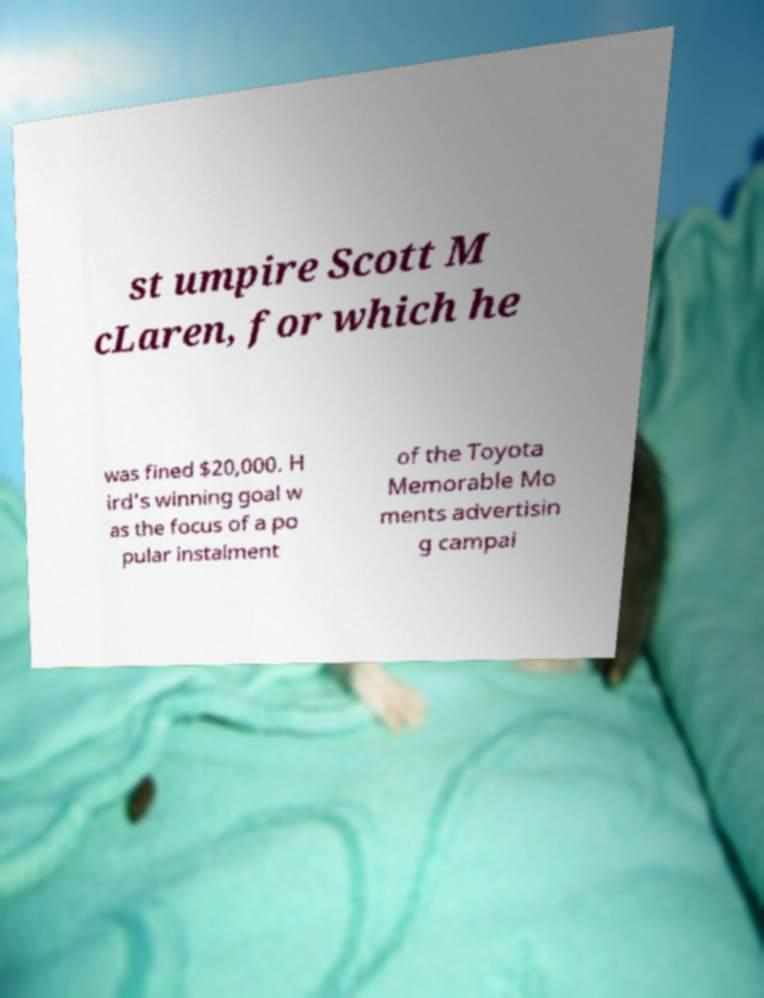I need the written content from this picture converted into text. Can you do that? st umpire Scott M cLaren, for which he was fined $20,000. H ird's winning goal w as the focus of a po pular instalment of the Toyota Memorable Mo ments advertisin g campai 